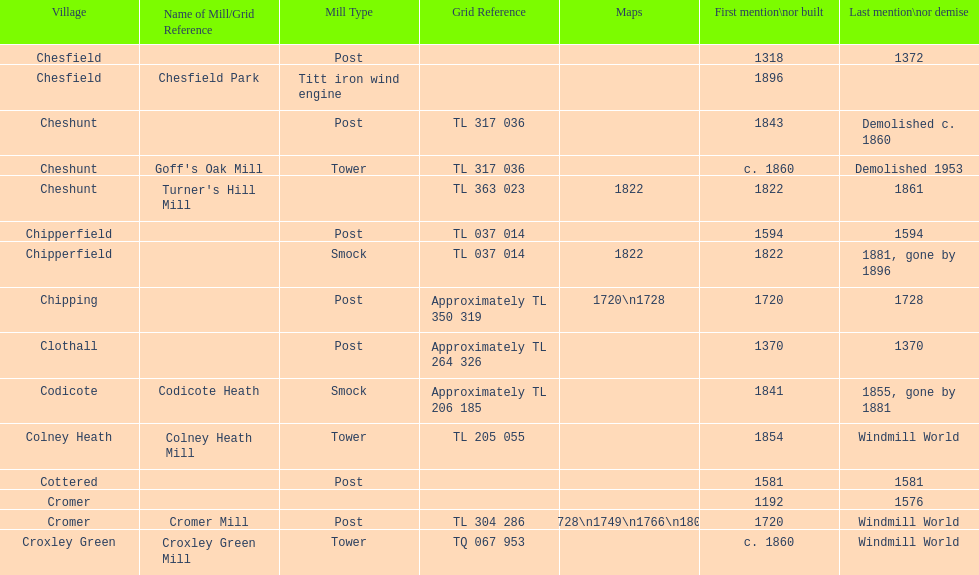What is the number of mills first mentioned or built in the 1800s? 8. 